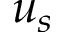Convert formula to latex. <formula><loc_0><loc_0><loc_500><loc_500>u _ { s }</formula> 